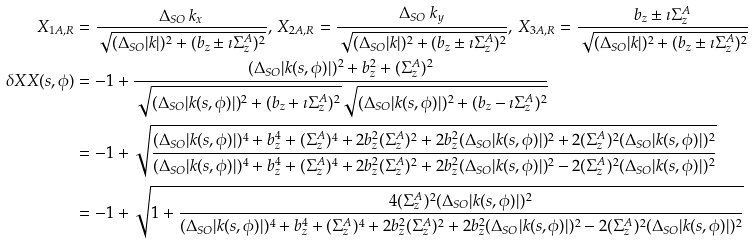Convert formula to latex. <formula><loc_0><loc_0><loc_500><loc_500>X _ { 1 A , R } & = \frac { \Delta _ { S O } \, k _ { x } } { \sqrt { ( \Delta _ { S O } | k | ) ^ { 2 } + ( b _ { z } \pm \imath \Sigma ^ { A } _ { z } ) ^ { 2 } } } , \, X _ { 2 A , R } = \frac { \Delta _ { S O } \, k _ { y } } { \sqrt { ( \Delta _ { S O } | k | ) ^ { 2 } + ( b _ { z } \pm \imath \Sigma ^ { A } _ { z } ) ^ { 2 } } } , \, X _ { 3 A , R } = \frac { b _ { z } \pm \imath \Sigma ^ { A } _ { z } } { \sqrt { ( \Delta _ { S O } | k | ) ^ { 2 } + ( b _ { z } \pm \imath \Sigma ^ { A } _ { z } ) ^ { 2 } } } \\ \delta X X ( s , \phi ) & = - 1 + \frac { ( \Delta _ { S O } | k ( s , \phi ) | ) ^ { 2 } + b _ { z } ^ { 2 } + ( \Sigma ^ { A } _ { z } ) ^ { 2 } } { \sqrt { ( \Delta _ { S O } | k ( s , \phi ) | ) ^ { 2 } + ( b _ { z } + \imath \Sigma ^ { A } _ { z } ) ^ { 2 } } \sqrt { ( \Delta _ { S O } | k ( s , \phi ) | ) ^ { 2 } + ( b _ { z } - \imath \Sigma ^ { A } _ { z } ) ^ { 2 } } } \\ & = - 1 + \sqrt { \frac { ( \Delta _ { S O } | k ( s , \phi ) | ) ^ { 4 } + b _ { z } ^ { 4 } + ( \Sigma ^ { A } _ { z } ) ^ { 4 } + 2 b _ { z } ^ { 2 } ( \Sigma ^ { A } _ { z } ) ^ { 2 } + 2 b _ { z } ^ { 2 } ( \Delta _ { S O } | k ( s , \phi ) | ) ^ { 2 } + 2 ( \Sigma ^ { A } _ { z } ) ^ { 2 } ( \Delta _ { S O } | k ( s , \phi ) | ) ^ { 2 } } { ( \Delta _ { S O } | k ( s , \phi ) | ) ^ { 4 } + b _ { z } ^ { 4 } + ( \Sigma ^ { A } _ { z } ) ^ { 4 } + 2 b _ { z } ^ { 2 } ( \Sigma ^ { A } _ { z } ) ^ { 2 } + 2 b _ { z } ^ { 2 } ( \Delta _ { S O } | k ( s , \phi ) | ) ^ { 2 } - 2 ( \Sigma ^ { A } _ { z } ) ^ { 2 } ( \Delta _ { S O } | k ( s , \phi ) | ) ^ { 2 } } } \\ & = - 1 + \sqrt { 1 + \frac { 4 ( \Sigma ^ { A } _ { z } ) ^ { 2 } ( \Delta _ { S O } | k ( s , \phi ) | ) ^ { 2 } } { ( \Delta _ { S O } | k ( s , \phi ) | ) ^ { 4 } + b _ { z } ^ { 4 } + ( \Sigma ^ { A } _ { z } ) ^ { 4 } + 2 b _ { z } ^ { 2 } ( \Sigma ^ { A } _ { z } ) ^ { 2 } + 2 b _ { z } ^ { 2 } ( \Delta _ { S O } | k ( s , \phi ) | ) ^ { 2 } - 2 ( \Sigma ^ { A } _ { z } ) ^ { 2 } ( \Delta _ { S O } | k ( s , \phi ) | ) ^ { 2 } } } \\</formula> 